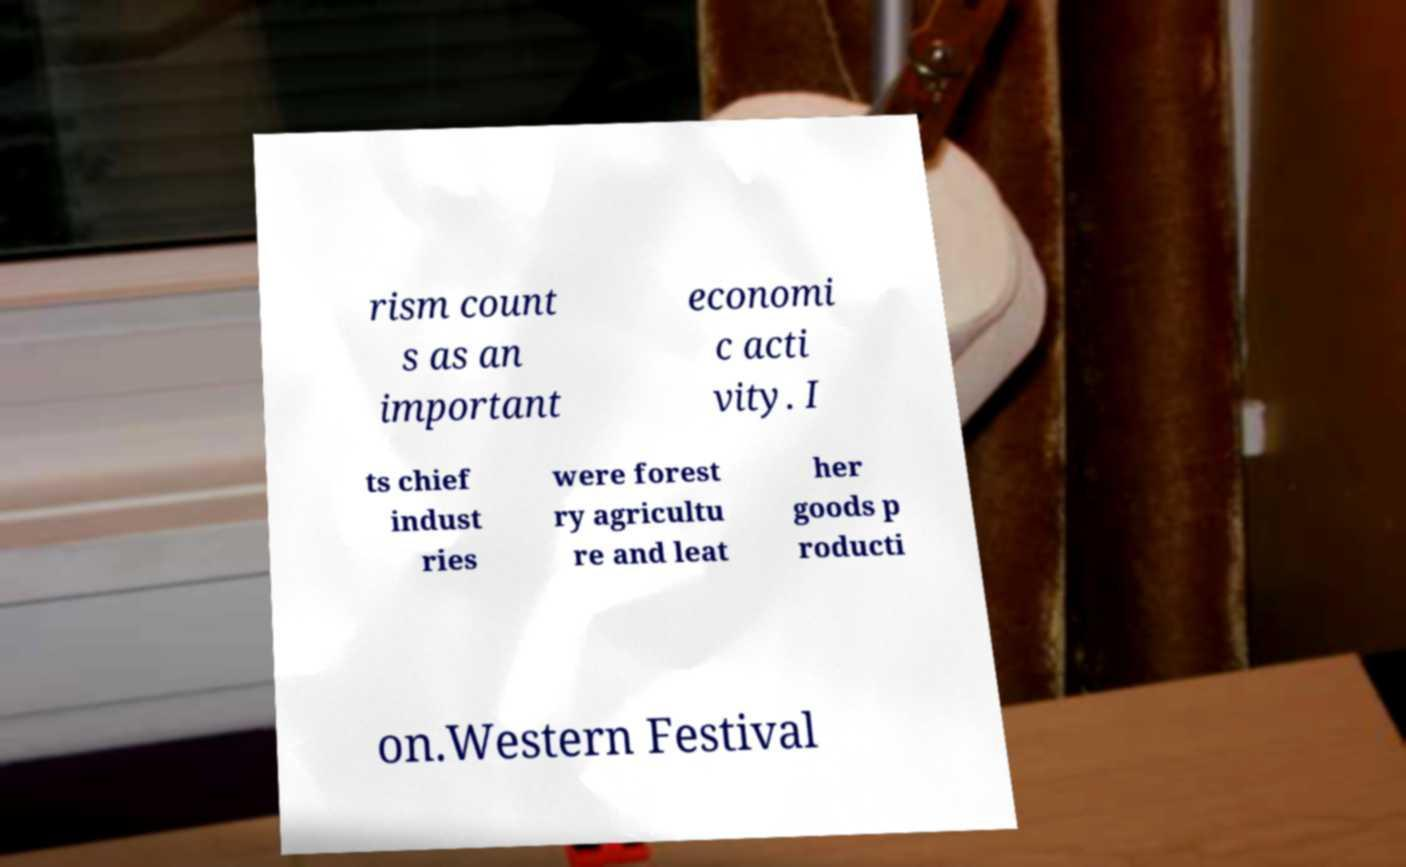I need the written content from this picture converted into text. Can you do that? rism count s as an important economi c acti vity. I ts chief indust ries were forest ry agricultu re and leat her goods p roducti on.Western Festival 